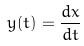Convert formula to latex. <formula><loc_0><loc_0><loc_500><loc_500>y ( t ) = \frac { d x } { d t }</formula> 